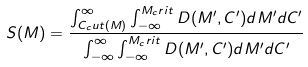<formula> <loc_0><loc_0><loc_500><loc_500>S ( M ) = \frac { \int _ { C _ { c } u t ( M ) } ^ { \infty } \int _ { - \infty } ^ { M _ { c } r i t } D ( M ^ { \prime } , C ^ { \prime } ) d M ^ { \prime } d C ^ { \prime } } { \int _ { - \infty } ^ { \infty } \int _ { - \infty } ^ { M _ { c } r i t } D ( M ^ { \prime } , C ^ { \prime } ) d M ^ { \prime } d C ^ { \prime } }</formula> 